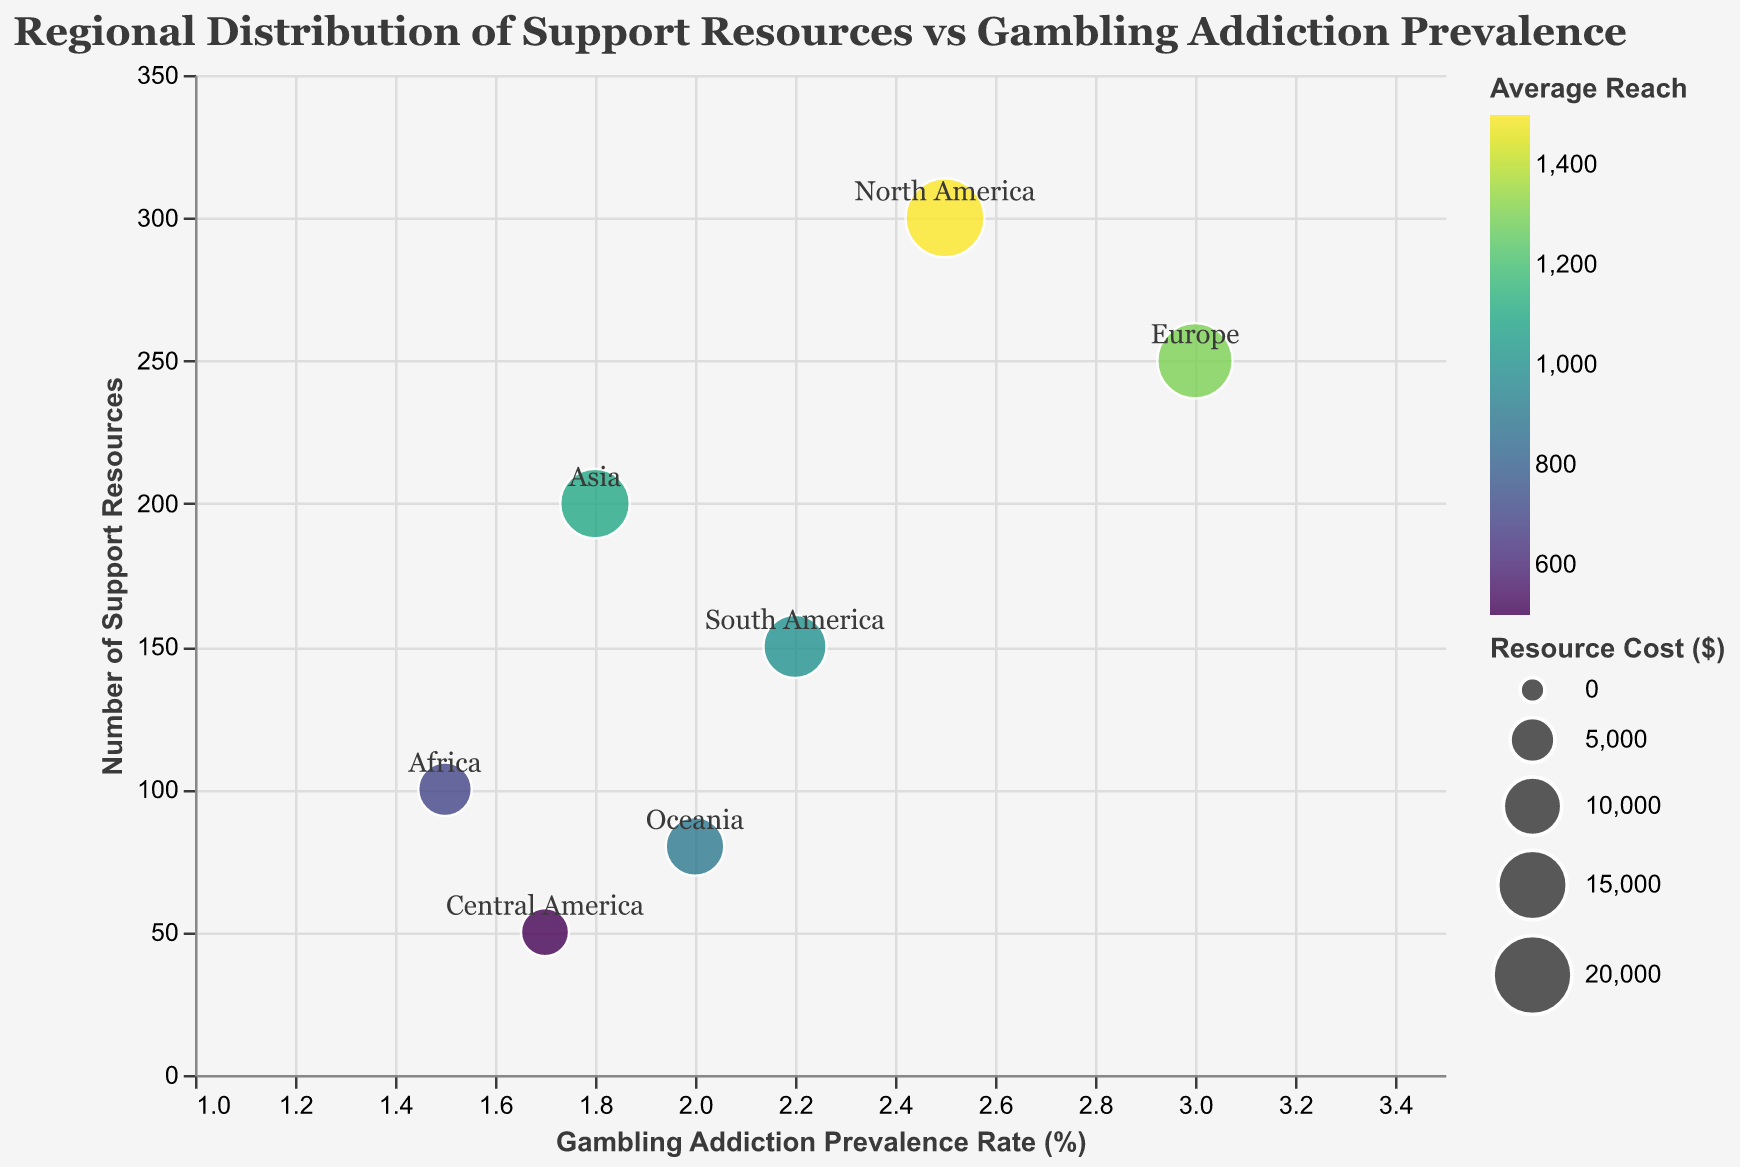What's the title of the chart? The title of the chart is located at the top and is written in a larger font size compared to other texts. It reads "Regional Distribution of Support Resources vs Gambling Addiction Prevalence".
Answer: Regional Distribution of Support Resources vs Gambling Addiction Prevalence Which region has the highest prevalence rate of gambling addiction? By looking at the x-axis, which represents the prevalence rate of gambling addiction, Europe has the highest value at 3.0.
Answer: Europe What is the number of support resources available in Oceania? Oceania is labeled on the chart, and by looking at its corresponding position on the y-axis, it shows 80 support resources.
Answer: 80 How does the resource cost for North America compare to South America? North America has a resource cost represented by the size of the bubble, which is larger compared to South America. Specifically, the resource cost for North America is $20000, while for South America, it is $12000.
Answer: North America's resource cost is greater than South America's Which region has the smallest average reach, and what is its value? The color scale on the chart indicates the average reach, with darker colors representing higher values. Central America, represented by a lighter shade, has the smallest average reach, which is 500.
Answer: Central America, 500 How do the support resources in Asia compare to Africa? Asia has 200 support resources while Africa has 100. By comparing the corresponding y-axis values, Asia has twice the number of support resources as Africa.
Answer: Asia has double the resources of Africa What region is most cost-effective if considering the cost per support resource? To determine cost-effectiveness, divide the Resource_Cost by Support_Resources. For example, Central America has a Resource_Cost of 6000 and Support_Resources of 50, yielding a cost-effectiveness ratio of 6000 / 50 = 120. Perform this calculation for all regions to identify the smallest ratio. Africa, with a Resource_Cost of 8000 and Support_Resources of 100, has 8000 / 100 = 80, which is the smallest ratio.
Answer: Africa What's the average support resources available across all regions? Sum up the Support_Resources for all regions (300 + 250 + 200 + 150 + 100 + 80 + 50 = 1130) and divide by the number of regions (7). The average is 1130 / 7 ≈ 161.4.
Answer: 161.4 Is there a region with a lower gambling addiction prevalence rate but more support resources than Oceania? Compare regions based on the x-axis (prevalence rate) less than 2.0 and y-axis (support resources) more than 80. Asia has a prevalence rate of 1.8 and 200 support resources, qualifying it for this criterion.
Answer: Asia has a lower prevalence rate but more support resources than Oceania 